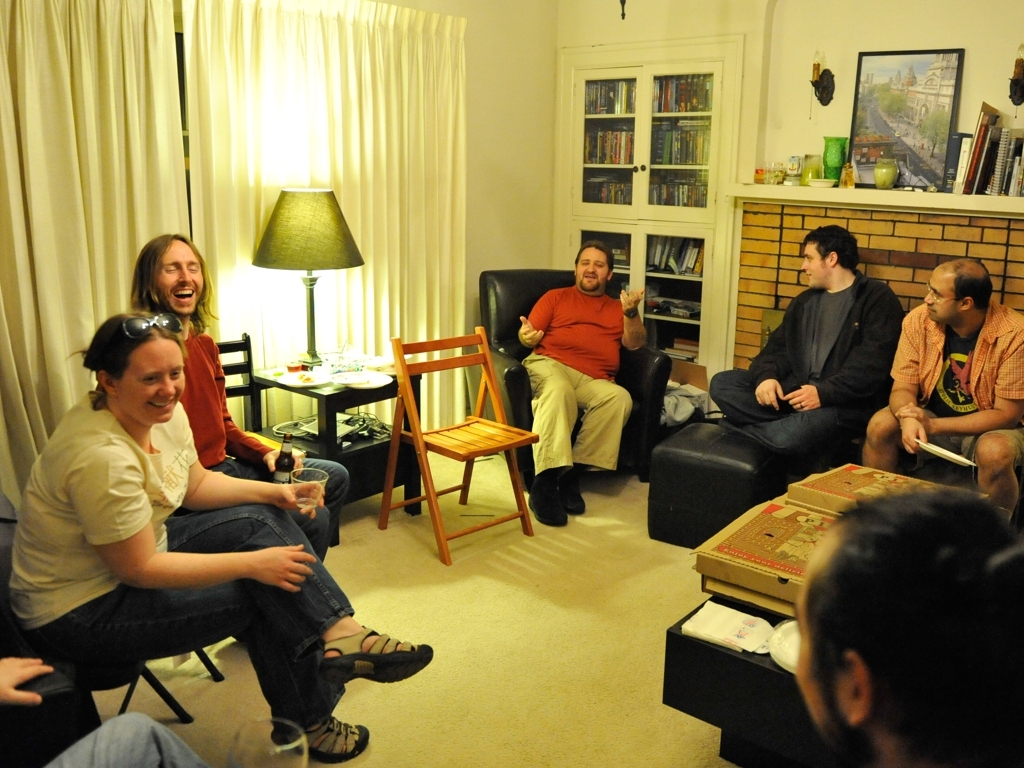Can you describe the setting of this picture? The setting is a cozy living room with a convivial and welcoming ambiance. The room is furnished with a mix of seating options, including chairs and sofas. There's a coffee table in the center, stacked with board games, which implies recreational activity. Bookshelves and personal items are visible in the background, providing a lived-in feel. Do the decorations or any items in the room stand out to you? A striking element is the framed artwork above the fireplace, which adds a touch of sophistication to the room. There's also an array of candles on the mantelpiece, which may suggest that the hosts enjoy creating a warm and inviting atmosphere. The bookshelves are crammed with books, indicating that the residents may be avid readers or collectors. 